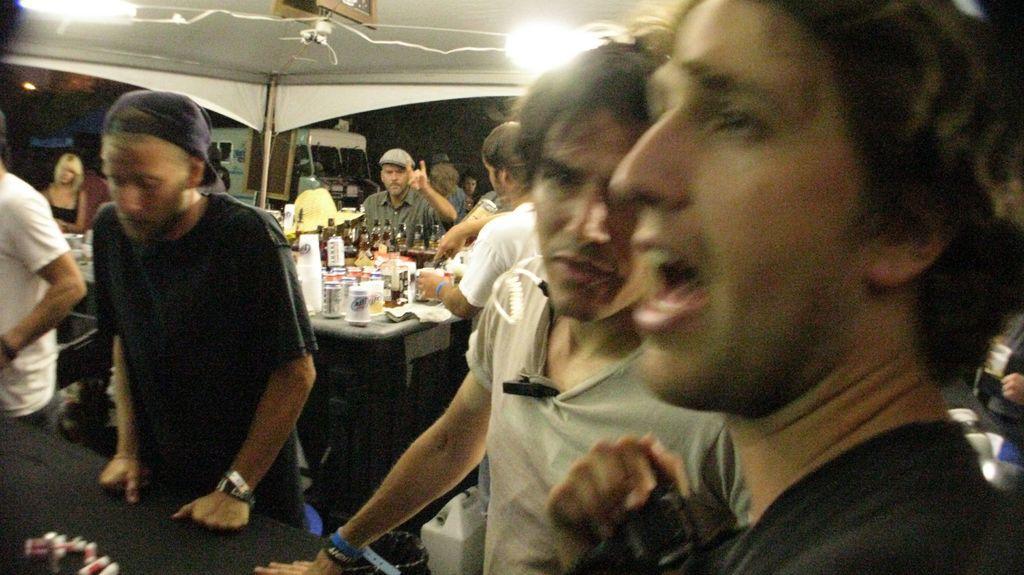Can you describe this image briefly? In this image we can see there are groups of people standing in the tent and there is a table, on the table there is a cloth, bottles, paper and a few objects. And there is a vehicle and a light. 